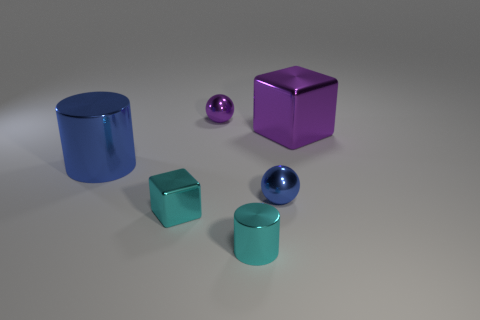Add 2 big purple metallic objects. How many objects exist? 8 Subtract all blue balls. How many balls are left? 1 Subtract all blocks. How many objects are left? 4 Subtract 2 spheres. How many spheres are left? 0 Subtract all tiny cylinders. Subtract all large objects. How many objects are left? 3 Add 2 blocks. How many blocks are left? 4 Add 3 blue shiny balls. How many blue shiny balls exist? 4 Subtract 1 purple spheres. How many objects are left? 5 Subtract all cyan cylinders. Subtract all brown blocks. How many cylinders are left? 1 